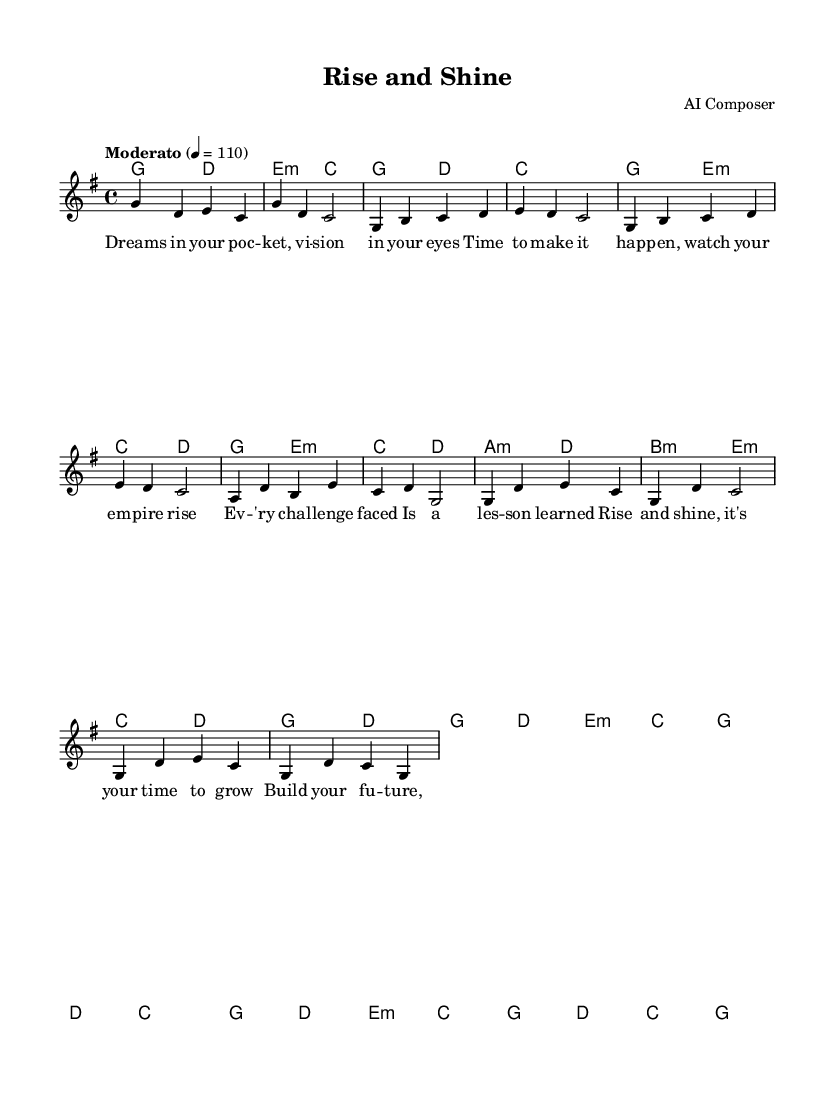What is the key signature of this music? The key signature is G major, which has one sharp (F#). This is indicated at the beginning of the score right after the clef.
Answer: G major What is the time signature of the piece? The time signature is 4/4. This is represented in the music score, typically seen at the start of the piece, indicating four beats per measure.
Answer: 4/4 What is the tempo marking of the piece? The tempo marking is Moderato, indicating a moderate speed. The number 110 indicates the beats per minute, providing a precise tempo.
Answer: Moderato How many measures are in the verse? The verse consists of 8 measures, as counted from the indicated section in the sheet music. Each set of 4 beats counts as one measure.
Answer: 8 measures What is the theme of the lyrics in the chorus? The theme of the lyrics in the chorus emphasizes personal growth and ambition. The lyrics encourage the listener to build a future and rise to their potential.
Answer: Personal growth What is the style of the piece? The style of this piece is motivational pop. The upbeat melody and encouraging lyrics reflect a pop music format aimed at inspiring the listener.
Answer: Motivational pop What chord does the music start with? The music starts with the G major chord as indicated in the harmonies section, marking the introduction of the piece.
Answer: G major 